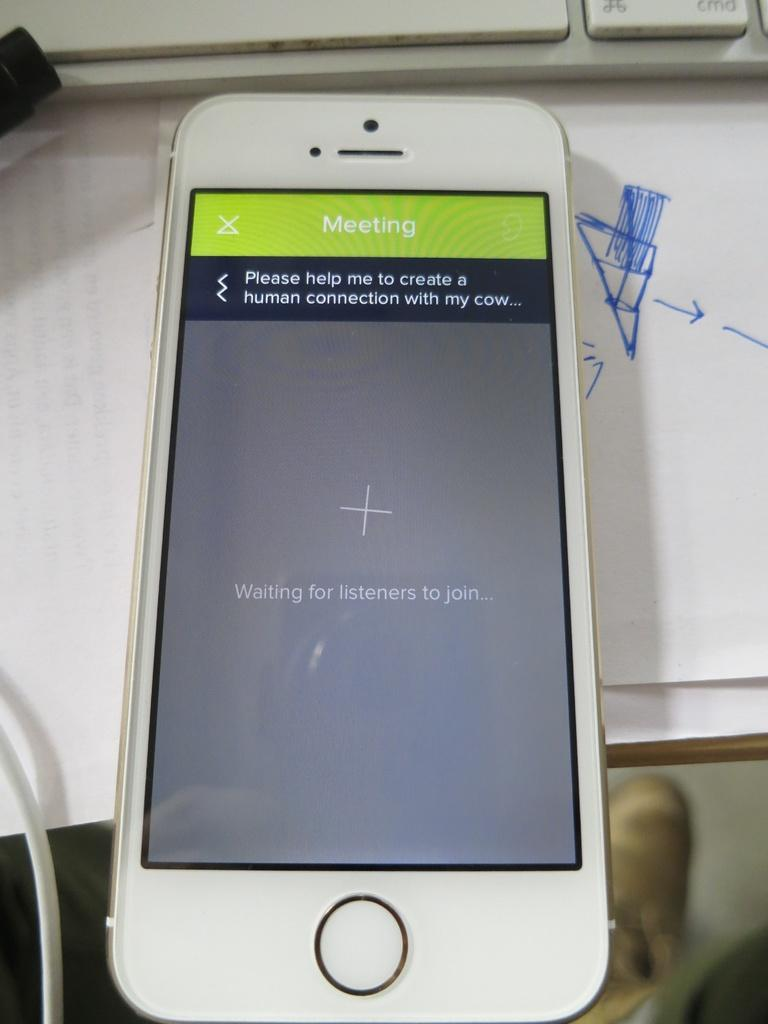Provide a one-sentence caption for the provided image. A cell phone reads Waiting for listeners to join on the screen. 